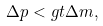<formula> <loc_0><loc_0><loc_500><loc_500>\Delta p < g t \Delta m ,</formula> 